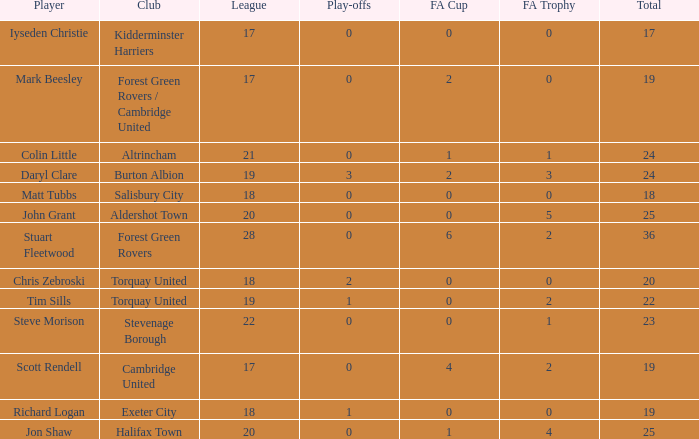Which of the lowest FA Trophys involved the Forest Green Rovers club when the play-offs number was bigger than 0? None. 